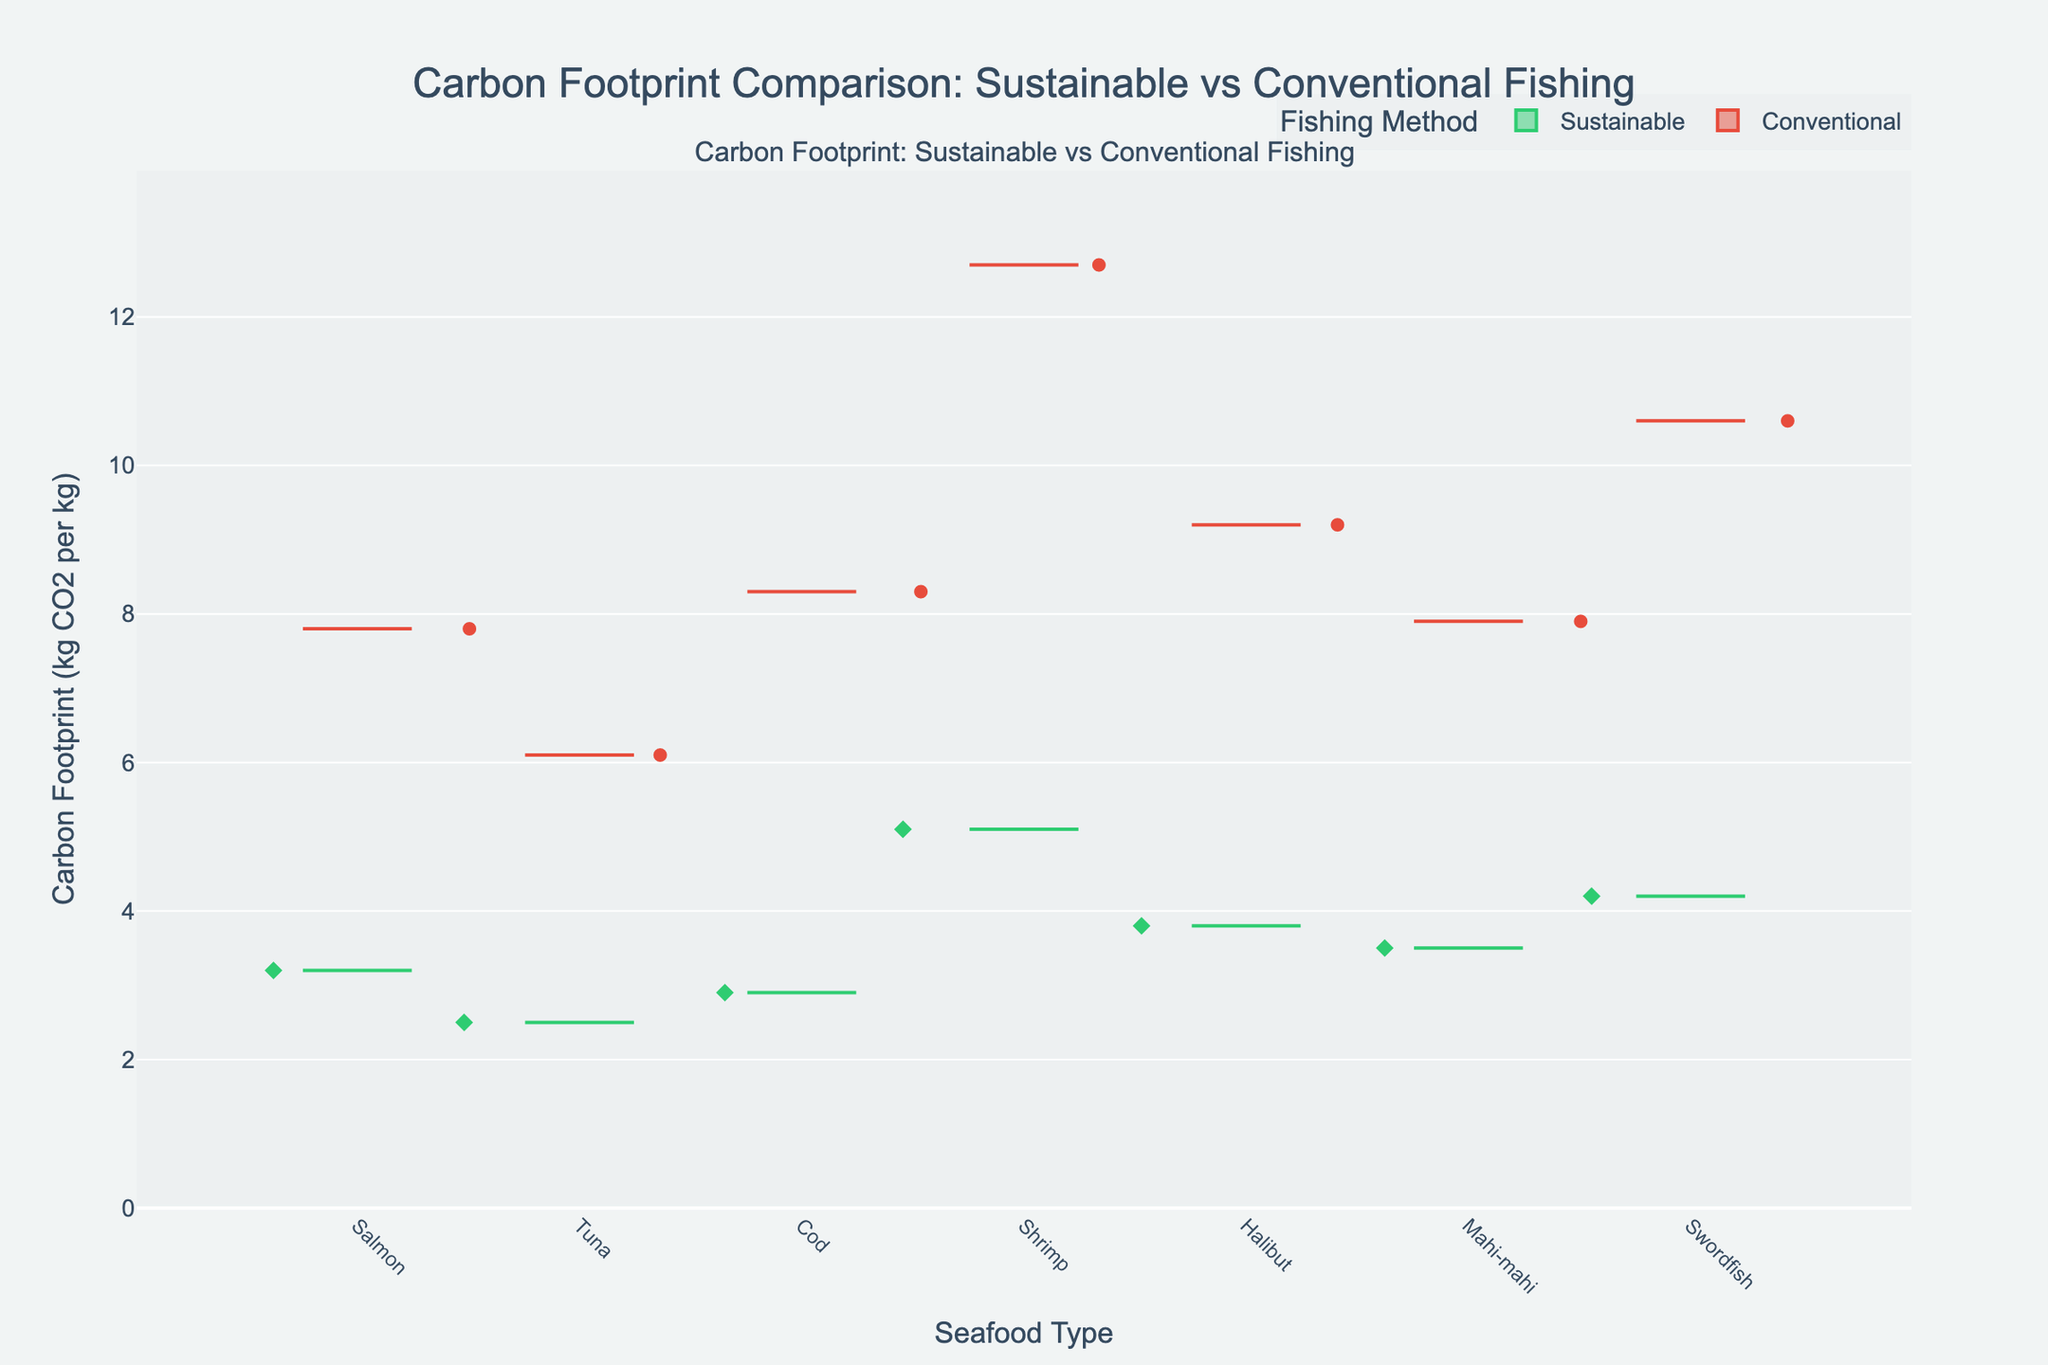What's the title of the figure? The title of the figure is visually located at the top and it summarizes the main theme of the plot. The title is "Carbon Footprint Comparison: Sustainable vs Conventional Fishing."
Answer: Carbon Footprint Comparison: Sustainable vs Conventional Fishing What are the two colors representing? The figure uses two distinct colors for differentiation. Green represents the sustainable fishing methods, and red represents the conventional fishing methods.
Answer: Green for Sustainable, Red for Conventional Which seafood type has the highest carbon footprint for conventional fishing? To determine this, look for the highest data point in the red boxes (representing conventional fishing methods). The highest point is seen with Shrimp, which has a carbon footprint of 12.7 kg CO2 per kg.
Answer: Shrimp Which seafood type shows the smallest difference in carbon footprint between sustainable and conventional fishing methods? To find this, compare the carbon footprints for each seafood type between the sustainable and conventional methods. The smallest difference is seen in Cod, with a sustainable footprint of 2.9 kg CO2 per kg and a conventional footprint of 8.3 kg CO2 per kg. The difference is 8.3 - 2.9 = 5.4 kg CO2 per kg.
Answer: Cod What is the carbon footprint of sustainably caught Tuna? Find the green box representing Tuna, which shows the carbon footprint for the sustainable fishing method (Pole and Line). The carbon footprint is 2.5 kg CO2 per kg.
Answer: 2.5 kg CO2 per kg What is the average carbon footprint of sustainably caught seafood across all types? Calculate the average of all carbon footprints within green boxes (sustainable methods). The values are 3.2, 2.5, 2.9, 5.1, 3.8, 3.5, and 4.2. The average is calculated as (3.2 + 2.5 + 2.9 + 5.1 + 3.8 + 3.5 + 4.2) / 7 ≈ 3.6 kg CO2 per kg.
Answer: 3.6 kg CO2 per kg How does the carbon footprint of sustainably caught Halibut compare to conventionally caught Halibut? Compare the heights of the green and red boxes (representing Halibut). The sustainable carbon footprint (Longline) is 3.8 kg CO2 per kg, and the conventional footprint (Gillnetting) is 9.2 kg CO2 per kg. The sustainable method has a lower footprint.
Answer: Sustainable: 3.8, Conventional: 9.2 Which seafood type has the widest range of carbon footprint values between the two fishing methods? Calculate the range for each seafood type by subtracting the sustainable footprint from the conventional footprint. The seafood type with the largest value indicates the widest range. Shrimp has the widest range (12.7 - 5.1 = 7.6 kg CO2 per kg).
Answer: Shrimp 